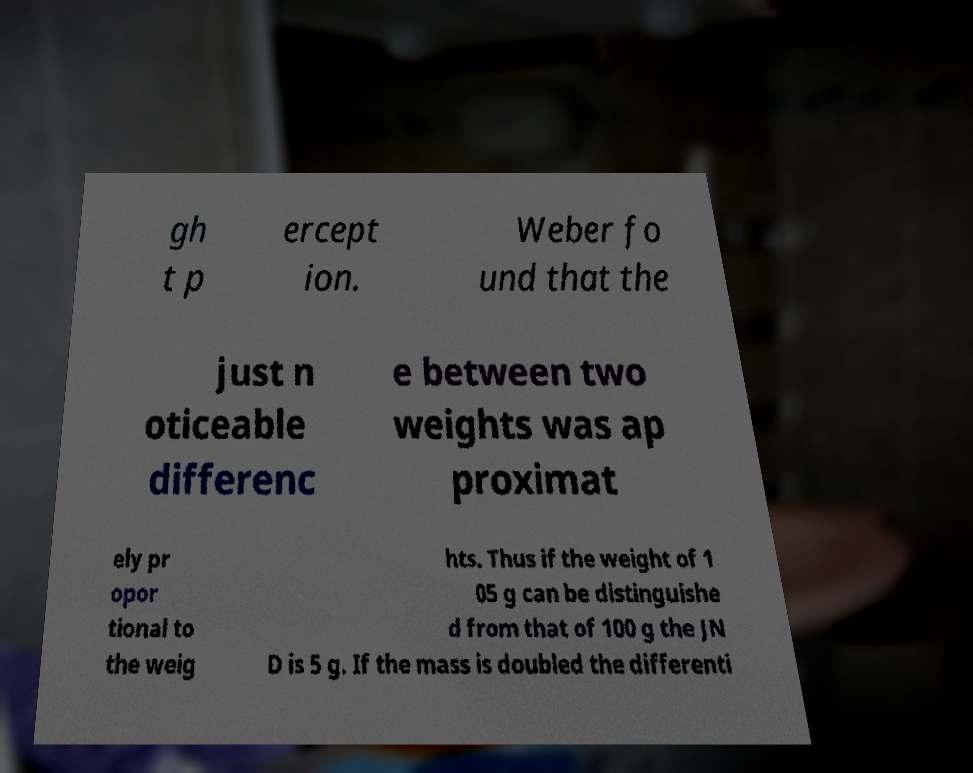I need the written content from this picture converted into text. Can you do that? gh t p ercept ion. Weber fo und that the just n oticeable differenc e between two weights was ap proximat ely pr opor tional to the weig hts. Thus if the weight of 1 05 g can be distinguishe d from that of 100 g the JN D is 5 g. If the mass is doubled the differenti 